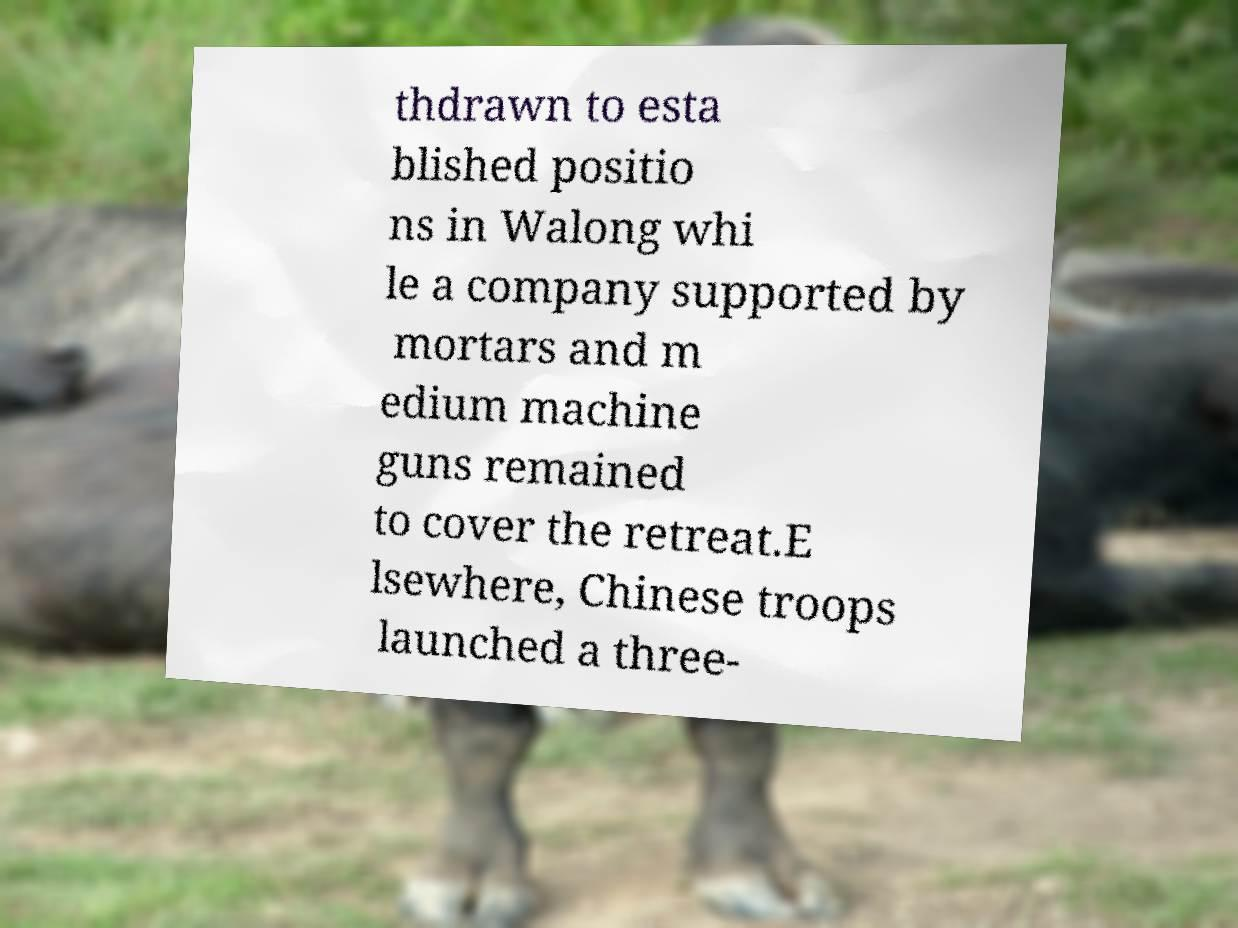Can you accurately transcribe the text from the provided image for me? thdrawn to esta blished positio ns in Walong whi le a company supported by mortars and m edium machine guns remained to cover the retreat.E lsewhere, Chinese troops launched a three- 